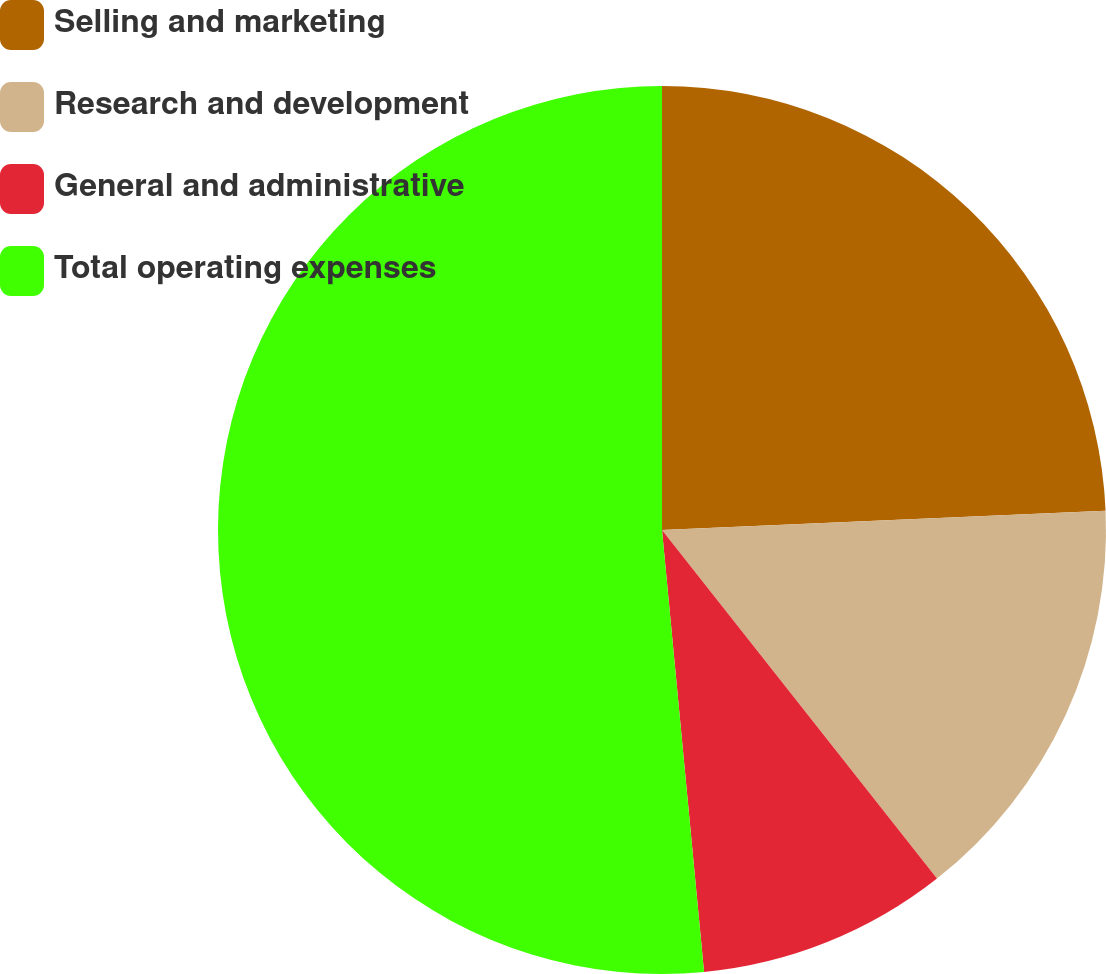<chart> <loc_0><loc_0><loc_500><loc_500><pie_chart><fcel>Selling and marketing<fcel>Research and development<fcel>General and administrative<fcel>Total operating expenses<nl><fcel>24.31%<fcel>15.06%<fcel>9.12%<fcel>51.51%<nl></chart> 